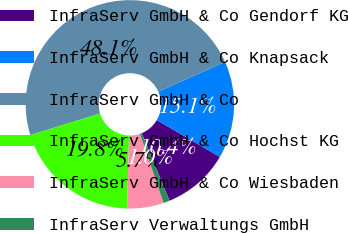<chart> <loc_0><loc_0><loc_500><loc_500><pie_chart><fcel>InfraServ GmbH & Co Gendorf KG<fcel>InfraServ GmbH & Co Knapsack<fcel>InfraServ GmbH & Co<fcel>InfraServ GmbH & Co Hochst KG<fcel>InfraServ GmbH & Co Wiesbaden<fcel>InfraServ Verwaltungs GmbH<nl><fcel>10.38%<fcel>15.09%<fcel>48.09%<fcel>19.81%<fcel>5.67%<fcel>0.96%<nl></chart> 